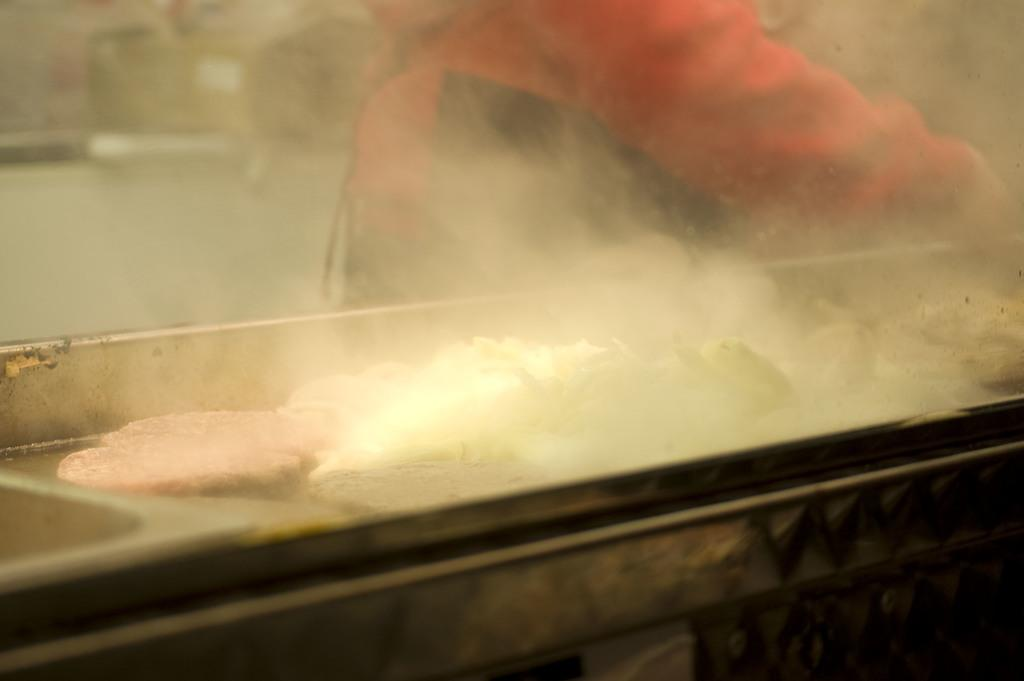Is there a bridge present in the image? There may be a bridge in the image. Can you identify any living beings in the image? There may be a person in the image. What can be seen in the image that is not a part of the landscape or a person? There is smoke visible in the image. What type of wing can be seen on the person in the image? There is no wing visible in the image, as there is no mention of a wing or a person with wings in the provided facts. 